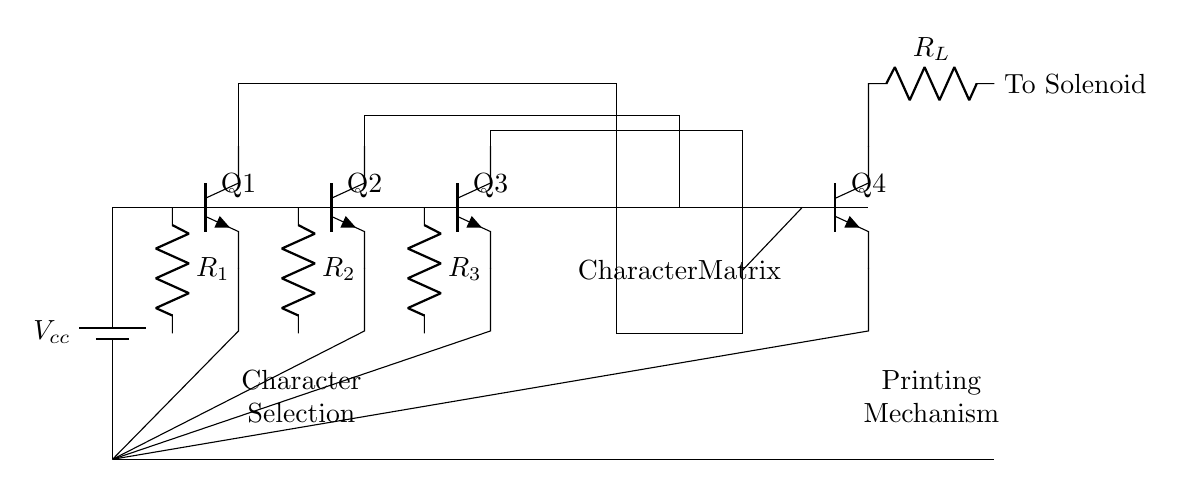What is the total number of transistors in this circuit? The circuit diagram shows four transistors labeled Q1, Q2, Q3, and Q4. These are represented as npn transistors, and each is identified clearly in the diagram.
Answer: Four What is the purpose of the resistors labeled R1, R2, and R3? The resistors R1, R2, and R3 are connected to the bases of the transistors Q1, Q2, and Q3 respectively. They are involved in the character selection mechanism, likely limiting the base current to control transistor operation.
Answer: Character selection What type of mechanism is used for printing in this circuit? The circuit features a printing mechanism which is indicated by the connection to the solenoid. The transistor Q4 and resistor R_L are part of this mechanism, suggesting the use of electro-mechanical means for printing.
Answer: Solenoid Which component is responsible for character selection? The character selection is performed by the transistors Q1, Q2, and Q3, which have connections indicating they control the pathways to a character matrix. They determine which character is selected based on their switching states.
Answer: Transistors What connects the character matrix to the printing mechanism? The connection from the character matrix to the printing mechanism is established through the transistor Q4, which presumably controls the flow to the printing mechanism once a character is selected.
Answer: Transistor Q4 What is the role of the component labeled as R_L? The resistor R_L is part of the circuit leading to the solenoid, likely serving as a load resistor that would help manage the current through the solenoid to actuate the printing mechanism as needed.
Answer: Load resistor 